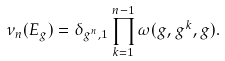Convert formula to latex. <formula><loc_0><loc_0><loc_500><loc_500>\nu _ { n } ( E _ { g } ) = \delta _ { g ^ { n } , 1 } \prod _ { k = 1 } ^ { n - 1 } \omega ( g , g ^ { k } , g ) .</formula> 